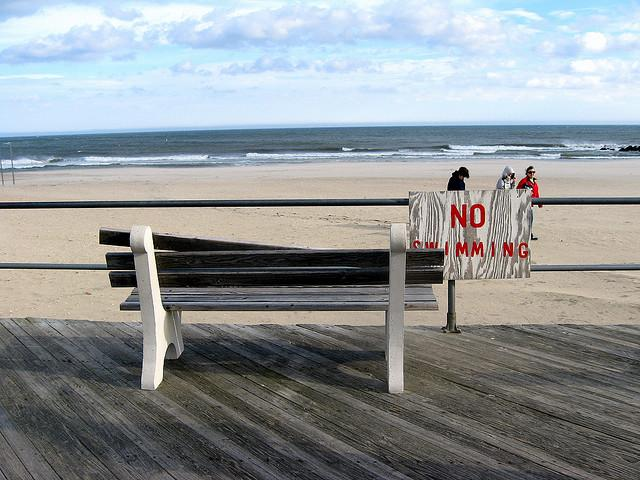What activity does the posted sign advise is not allowed? Please explain your reasoning. swimming. Its in red letters and says what you can do with water. 